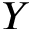Convert formula to latex. <formula><loc_0><loc_0><loc_500><loc_500>Y</formula> 